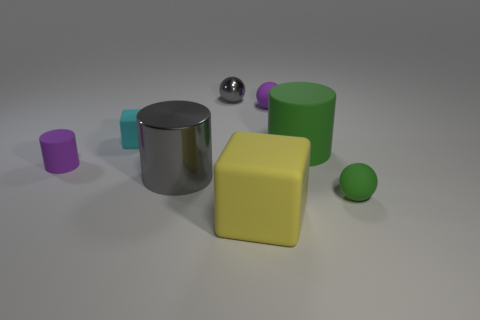Add 2 gray metal things. How many objects exist? 10 Subtract all balls. How many objects are left? 5 Subtract all tiny purple matte cylinders. Subtract all rubber blocks. How many objects are left? 5 Add 8 purple cylinders. How many purple cylinders are left? 9 Add 8 gray metallic cylinders. How many gray metallic cylinders exist? 9 Subtract 1 cyan cubes. How many objects are left? 7 